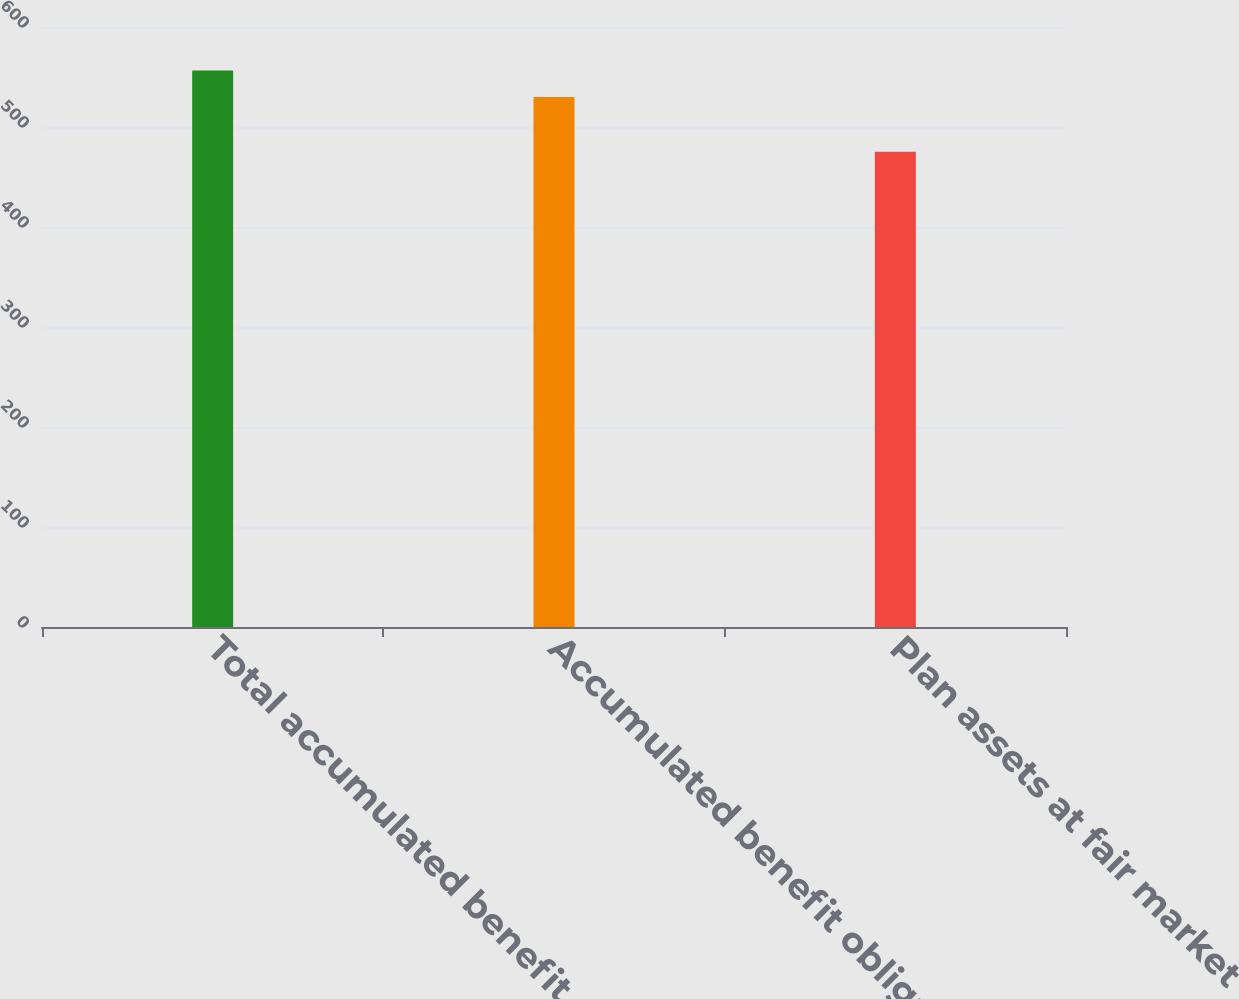<chart> <loc_0><loc_0><loc_500><loc_500><bar_chart><fcel>Total accumulated benefit<fcel>Accumulated benefit obligation<fcel>Plan assets at fair market<nl><fcel>556.4<fcel>530.1<fcel>475.3<nl></chart> 